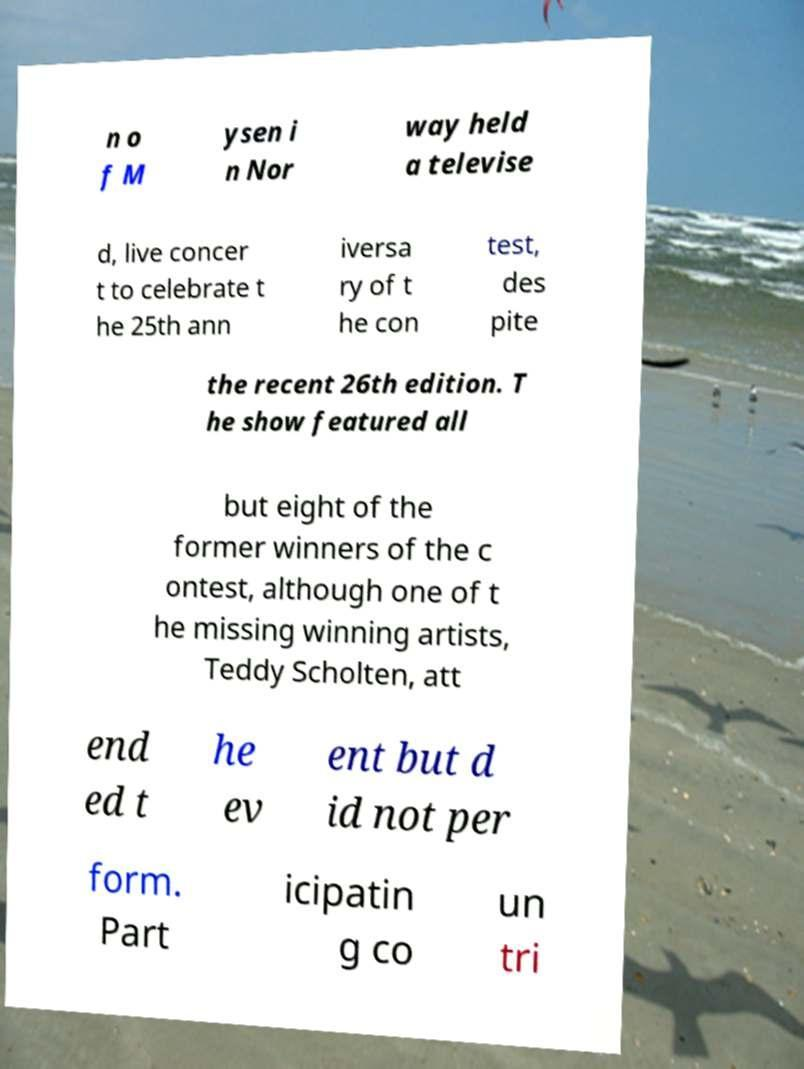Could you assist in decoding the text presented in this image and type it out clearly? n o f M ysen i n Nor way held a televise d, live concer t to celebrate t he 25th ann iversa ry of t he con test, des pite the recent 26th edition. T he show featured all but eight of the former winners of the c ontest, although one of t he missing winning artists, Teddy Scholten, att end ed t he ev ent but d id not per form. Part icipatin g co un tri 